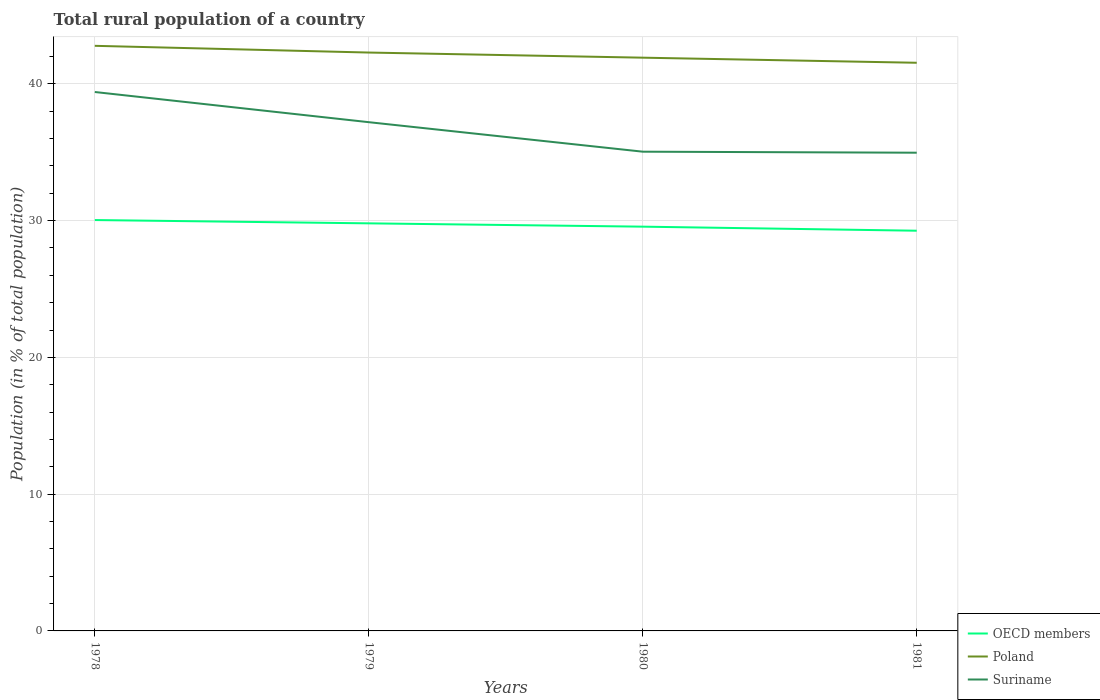How many different coloured lines are there?
Provide a short and direct response. 3. Does the line corresponding to Suriname intersect with the line corresponding to Poland?
Keep it short and to the point. No. Across all years, what is the maximum rural population in Poland?
Make the answer very short. 41.54. In which year was the rural population in OECD members maximum?
Keep it short and to the point. 1981. What is the total rural population in OECD members in the graph?
Give a very brief answer. 0.78. What is the difference between the highest and the second highest rural population in Suriname?
Provide a short and direct response. 4.44. What is the difference between the highest and the lowest rural population in OECD members?
Your response must be concise. 2. Is the rural population in Poland strictly greater than the rural population in OECD members over the years?
Provide a succinct answer. No. How many lines are there?
Offer a terse response. 3. Does the graph contain any zero values?
Your answer should be compact. No. Where does the legend appear in the graph?
Ensure brevity in your answer.  Bottom right. How many legend labels are there?
Provide a succinct answer. 3. How are the legend labels stacked?
Your response must be concise. Vertical. What is the title of the graph?
Your response must be concise. Total rural population of a country. What is the label or title of the X-axis?
Ensure brevity in your answer.  Years. What is the label or title of the Y-axis?
Provide a short and direct response. Population (in % of total population). What is the Population (in % of total population) in OECD members in 1978?
Offer a terse response. 30.04. What is the Population (in % of total population) in Poland in 1978?
Make the answer very short. 42.78. What is the Population (in % of total population) of Suriname in 1978?
Your answer should be very brief. 39.4. What is the Population (in % of total population) of OECD members in 1979?
Provide a succinct answer. 29.8. What is the Population (in % of total population) of Poland in 1979?
Offer a terse response. 42.29. What is the Population (in % of total population) of Suriname in 1979?
Give a very brief answer. 37.2. What is the Population (in % of total population) in OECD members in 1980?
Make the answer very short. 29.56. What is the Population (in % of total population) in Poland in 1980?
Give a very brief answer. 41.91. What is the Population (in % of total population) of Suriname in 1980?
Offer a very short reply. 35.04. What is the Population (in % of total population) of OECD members in 1981?
Provide a short and direct response. 29.26. What is the Population (in % of total population) of Poland in 1981?
Provide a short and direct response. 41.54. What is the Population (in % of total population) in Suriname in 1981?
Provide a short and direct response. 34.97. Across all years, what is the maximum Population (in % of total population) in OECD members?
Make the answer very short. 30.04. Across all years, what is the maximum Population (in % of total population) of Poland?
Provide a succinct answer. 42.78. Across all years, what is the maximum Population (in % of total population) of Suriname?
Your answer should be compact. 39.4. Across all years, what is the minimum Population (in % of total population) in OECD members?
Provide a succinct answer. 29.26. Across all years, what is the minimum Population (in % of total population) of Poland?
Your response must be concise. 41.54. Across all years, what is the minimum Population (in % of total population) of Suriname?
Keep it short and to the point. 34.97. What is the total Population (in % of total population) in OECD members in the graph?
Offer a terse response. 118.66. What is the total Population (in % of total population) of Poland in the graph?
Give a very brief answer. 168.52. What is the total Population (in % of total population) in Suriname in the graph?
Give a very brief answer. 146.6. What is the difference between the Population (in % of total population) of OECD members in 1978 and that in 1979?
Your answer should be compact. 0.24. What is the difference between the Population (in % of total population) in Poland in 1978 and that in 1979?
Give a very brief answer. 0.49. What is the difference between the Population (in % of total population) of Suriname in 1978 and that in 1979?
Make the answer very short. 2.21. What is the difference between the Population (in % of total population) of OECD members in 1978 and that in 1980?
Give a very brief answer. 0.48. What is the difference between the Population (in % of total population) in Poland in 1978 and that in 1980?
Make the answer very short. 0.87. What is the difference between the Population (in % of total population) of Suriname in 1978 and that in 1980?
Your response must be concise. 4.36. What is the difference between the Population (in % of total population) in OECD members in 1978 and that in 1981?
Give a very brief answer. 0.78. What is the difference between the Population (in % of total population) in Poland in 1978 and that in 1981?
Your answer should be very brief. 1.24. What is the difference between the Population (in % of total population) in Suriname in 1978 and that in 1981?
Provide a short and direct response. 4.44. What is the difference between the Population (in % of total population) of OECD members in 1979 and that in 1980?
Make the answer very short. 0.24. What is the difference between the Population (in % of total population) of Poland in 1979 and that in 1980?
Ensure brevity in your answer.  0.37. What is the difference between the Population (in % of total population) in Suriname in 1979 and that in 1980?
Offer a terse response. 2.16. What is the difference between the Population (in % of total population) in OECD members in 1979 and that in 1981?
Give a very brief answer. 0.54. What is the difference between the Population (in % of total population) of Poland in 1979 and that in 1981?
Your response must be concise. 0.75. What is the difference between the Population (in % of total population) of Suriname in 1979 and that in 1981?
Keep it short and to the point. 2.23. What is the difference between the Population (in % of total population) in OECD members in 1980 and that in 1981?
Offer a very short reply. 0.3. What is the difference between the Population (in % of total population) of Poland in 1980 and that in 1981?
Offer a terse response. 0.37. What is the difference between the Population (in % of total population) in Suriname in 1980 and that in 1981?
Your answer should be very brief. 0.07. What is the difference between the Population (in % of total population) in OECD members in 1978 and the Population (in % of total population) in Poland in 1979?
Offer a very short reply. -12.25. What is the difference between the Population (in % of total population) in OECD members in 1978 and the Population (in % of total population) in Suriname in 1979?
Keep it short and to the point. -7.16. What is the difference between the Population (in % of total population) in Poland in 1978 and the Population (in % of total population) in Suriname in 1979?
Keep it short and to the point. 5.58. What is the difference between the Population (in % of total population) of OECD members in 1978 and the Population (in % of total population) of Poland in 1980?
Ensure brevity in your answer.  -11.87. What is the difference between the Population (in % of total population) in OECD members in 1978 and the Population (in % of total population) in Suriname in 1980?
Ensure brevity in your answer.  -5. What is the difference between the Population (in % of total population) in Poland in 1978 and the Population (in % of total population) in Suriname in 1980?
Give a very brief answer. 7.74. What is the difference between the Population (in % of total population) in OECD members in 1978 and the Population (in % of total population) in Poland in 1981?
Keep it short and to the point. -11.5. What is the difference between the Population (in % of total population) of OECD members in 1978 and the Population (in % of total population) of Suriname in 1981?
Your answer should be very brief. -4.92. What is the difference between the Population (in % of total population) in Poland in 1978 and the Population (in % of total population) in Suriname in 1981?
Provide a succinct answer. 7.82. What is the difference between the Population (in % of total population) of OECD members in 1979 and the Population (in % of total population) of Poland in 1980?
Offer a terse response. -12.11. What is the difference between the Population (in % of total population) in OECD members in 1979 and the Population (in % of total population) in Suriname in 1980?
Your answer should be compact. -5.24. What is the difference between the Population (in % of total population) in Poland in 1979 and the Population (in % of total population) in Suriname in 1980?
Provide a short and direct response. 7.25. What is the difference between the Population (in % of total population) in OECD members in 1979 and the Population (in % of total population) in Poland in 1981?
Keep it short and to the point. -11.74. What is the difference between the Population (in % of total population) of OECD members in 1979 and the Population (in % of total population) of Suriname in 1981?
Keep it short and to the point. -5.16. What is the difference between the Population (in % of total population) in Poland in 1979 and the Population (in % of total population) in Suriname in 1981?
Your answer should be compact. 7.32. What is the difference between the Population (in % of total population) of OECD members in 1980 and the Population (in % of total population) of Poland in 1981?
Your answer should be compact. -11.98. What is the difference between the Population (in % of total population) in OECD members in 1980 and the Population (in % of total population) in Suriname in 1981?
Make the answer very short. -5.41. What is the difference between the Population (in % of total population) of Poland in 1980 and the Population (in % of total population) of Suriname in 1981?
Offer a terse response. 6.95. What is the average Population (in % of total population) of OECD members per year?
Give a very brief answer. 29.67. What is the average Population (in % of total population) of Poland per year?
Keep it short and to the point. 42.13. What is the average Population (in % of total population) of Suriname per year?
Ensure brevity in your answer.  36.65. In the year 1978, what is the difference between the Population (in % of total population) of OECD members and Population (in % of total population) of Poland?
Your response must be concise. -12.74. In the year 1978, what is the difference between the Population (in % of total population) in OECD members and Population (in % of total population) in Suriname?
Make the answer very short. -9.36. In the year 1978, what is the difference between the Population (in % of total population) in Poland and Population (in % of total population) in Suriname?
Keep it short and to the point. 3.38. In the year 1979, what is the difference between the Population (in % of total population) in OECD members and Population (in % of total population) in Poland?
Keep it short and to the point. -12.49. In the year 1979, what is the difference between the Population (in % of total population) in OECD members and Population (in % of total population) in Suriname?
Ensure brevity in your answer.  -7.4. In the year 1979, what is the difference between the Population (in % of total population) in Poland and Population (in % of total population) in Suriname?
Offer a very short reply. 5.09. In the year 1980, what is the difference between the Population (in % of total population) of OECD members and Population (in % of total population) of Poland?
Provide a short and direct response. -12.36. In the year 1980, what is the difference between the Population (in % of total population) of OECD members and Population (in % of total population) of Suriname?
Ensure brevity in your answer.  -5.48. In the year 1980, what is the difference between the Population (in % of total population) in Poland and Population (in % of total population) in Suriname?
Your response must be concise. 6.87. In the year 1981, what is the difference between the Population (in % of total population) in OECD members and Population (in % of total population) in Poland?
Offer a terse response. -12.28. In the year 1981, what is the difference between the Population (in % of total population) in OECD members and Population (in % of total population) in Suriname?
Provide a succinct answer. -5.7. In the year 1981, what is the difference between the Population (in % of total population) of Poland and Population (in % of total population) of Suriname?
Make the answer very short. 6.58. What is the ratio of the Population (in % of total population) of OECD members in 1978 to that in 1979?
Give a very brief answer. 1.01. What is the ratio of the Population (in % of total population) in Poland in 1978 to that in 1979?
Give a very brief answer. 1.01. What is the ratio of the Population (in % of total population) in Suriname in 1978 to that in 1979?
Make the answer very short. 1.06. What is the ratio of the Population (in % of total population) in OECD members in 1978 to that in 1980?
Provide a succinct answer. 1.02. What is the ratio of the Population (in % of total population) of Poland in 1978 to that in 1980?
Ensure brevity in your answer.  1.02. What is the ratio of the Population (in % of total population) in Suriname in 1978 to that in 1980?
Give a very brief answer. 1.12. What is the ratio of the Population (in % of total population) in OECD members in 1978 to that in 1981?
Your answer should be compact. 1.03. What is the ratio of the Population (in % of total population) of Poland in 1978 to that in 1981?
Your answer should be compact. 1.03. What is the ratio of the Population (in % of total population) of Suriname in 1978 to that in 1981?
Your response must be concise. 1.13. What is the ratio of the Population (in % of total population) in OECD members in 1979 to that in 1980?
Your response must be concise. 1.01. What is the ratio of the Population (in % of total population) of Poland in 1979 to that in 1980?
Offer a terse response. 1.01. What is the ratio of the Population (in % of total population) of Suriname in 1979 to that in 1980?
Provide a short and direct response. 1.06. What is the ratio of the Population (in % of total population) in OECD members in 1979 to that in 1981?
Provide a succinct answer. 1.02. What is the ratio of the Population (in % of total population) in Suriname in 1979 to that in 1981?
Your response must be concise. 1.06. What is the ratio of the Population (in % of total population) in OECD members in 1980 to that in 1981?
Your answer should be compact. 1.01. What is the ratio of the Population (in % of total population) in Poland in 1980 to that in 1981?
Your answer should be very brief. 1.01. What is the difference between the highest and the second highest Population (in % of total population) of OECD members?
Give a very brief answer. 0.24. What is the difference between the highest and the second highest Population (in % of total population) in Poland?
Ensure brevity in your answer.  0.49. What is the difference between the highest and the second highest Population (in % of total population) in Suriname?
Your answer should be compact. 2.21. What is the difference between the highest and the lowest Population (in % of total population) of OECD members?
Keep it short and to the point. 0.78. What is the difference between the highest and the lowest Population (in % of total population) of Poland?
Offer a terse response. 1.24. What is the difference between the highest and the lowest Population (in % of total population) in Suriname?
Your response must be concise. 4.44. 